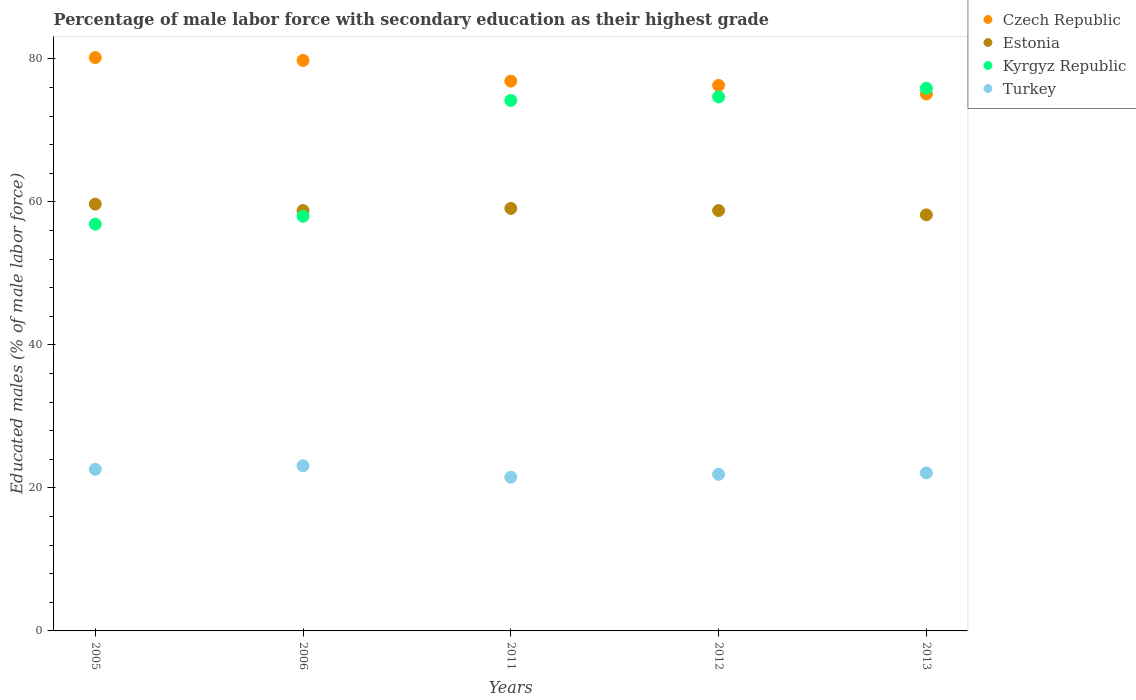Is the number of dotlines equal to the number of legend labels?
Your answer should be very brief. Yes. What is the percentage of male labor force with secondary education in Estonia in 2006?
Your response must be concise. 58.8. Across all years, what is the maximum percentage of male labor force with secondary education in Czech Republic?
Offer a terse response. 80.2. Across all years, what is the minimum percentage of male labor force with secondary education in Kyrgyz Republic?
Give a very brief answer. 56.9. What is the total percentage of male labor force with secondary education in Kyrgyz Republic in the graph?
Offer a terse response. 339.7. What is the difference between the percentage of male labor force with secondary education in Czech Republic in 2006 and that in 2013?
Provide a succinct answer. 4.7. What is the difference between the percentage of male labor force with secondary education in Turkey in 2006 and the percentage of male labor force with secondary education in Estonia in 2012?
Offer a terse response. -35.7. What is the average percentage of male labor force with secondary education in Kyrgyz Republic per year?
Provide a succinct answer. 67.94. In the year 2013, what is the difference between the percentage of male labor force with secondary education in Estonia and percentage of male labor force with secondary education in Turkey?
Offer a very short reply. 36.1. In how many years, is the percentage of male labor force with secondary education in Kyrgyz Republic greater than 44 %?
Make the answer very short. 5. What is the ratio of the percentage of male labor force with secondary education in Turkey in 2005 to that in 2012?
Give a very brief answer. 1.03. Is the difference between the percentage of male labor force with secondary education in Estonia in 2005 and 2012 greater than the difference between the percentage of male labor force with secondary education in Turkey in 2005 and 2012?
Offer a terse response. Yes. What is the difference between the highest and the second highest percentage of male labor force with secondary education in Kyrgyz Republic?
Give a very brief answer. 1.2. What is the difference between the highest and the lowest percentage of male labor force with secondary education in Czech Republic?
Make the answer very short. 5.1. In how many years, is the percentage of male labor force with secondary education in Turkey greater than the average percentage of male labor force with secondary education in Turkey taken over all years?
Ensure brevity in your answer.  2. Is the sum of the percentage of male labor force with secondary education in Turkey in 2011 and 2012 greater than the maximum percentage of male labor force with secondary education in Estonia across all years?
Give a very brief answer. No. Is it the case that in every year, the sum of the percentage of male labor force with secondary education in Estonia and percentage of male labor force with secondary education in Kyrgyz Republic  is greater than the sum of percentage of male labor force with secondary education in Czech Republic and percentage of male labor force with secondary education in Turkey?
Ensure brevity in your answer.  Yes. Does the percentage of male labor force with secondary education in Czech Republic monotonically increase over the years?
Ensure brevity in your answer.  No. Is the percentage of male labor force with secondary education in Kyrgyz Republic strictly greater than the percentage of male labor force with secondary education in Czech Republic over the years?
Ensure brevity in your answer.  No. Is the percentage of male labor force with secondary education in Czech Republic strictly less than the percentage of male labor force with secondary education in Turkey over the years?
Provide a short and direct response. No. How many years are there in the graph?
Your answer should be very brief. 5. Are the values on the major ticks of Y-axis written in scientific E-notation?
Your answer should be very brief. No. Does the graph contain any zero values?
Your answer should be compact. No. Does the graph contain grids?
Your response must be concise. No. How are the legend labels stacked?
Give a very brief answer. Vertical. What is the title of the graph?
Ensure brevity in your answer.  Percentage of male labor force with secondary education as their highest grade. Does "Uzbekistan" appear as one of the legend labels in the graph?
Your answer should be very brief. No. What is the label or title of the Y-axis?
Give a very brief answer. Educated males (% of male labor force). What is the Educated males (% of male labor force) of Czech Republic in 2005?
Keep it short and to the point. 80.2. What is the Educated males (% of male labor force) in Estonia in 2005?
Offer a terse response. 59.7. What is the Educated males (% of male labor force) in Kyrgyz Republic in 2005?
Make the answer very short. 56.9. What is the Educated males (% of male labor force) of Turkey in 2005?
Offer a very short reply. 22.6. What is the Educated males (% of male labor force) of Czech Republic in 2006?
Your answer should be very brief. 79.8. What is the Educated males (% of male labor force) of Estonia in 2006?
Your answer should be very brief. 58.8. What is the Educated males (% of male labor force) of Turkey in 2006?
Provide a succinct answer. 23.1. What is the Educated males (% of male labor force) of Czech Republic in 2011?
Offer a terse response. 76.9. What is the Educated males (% of male labor force) of Estonia in 2011?
Keep it short and to the point. 59.1. What is the Educated males (% of male labor force) in Kyrgyz Republic in 2011?
Ensure brevity in your answer.  74.2. What is the Educated males (% of male labor force) of Turkey in 2011?
Provide a short and direct response. 21.5. What is the Educated males (% of male labor force) of Czech Republic in 2012?
Keep it short and to the point. 76.3. What is the Educated males (% of male labor force) in Estonia in 2012?
Provide a short and direct response. 58.8. What is the Educated males (% of male labor force) in Kyrgyz Republic in 2012?
Keep it short and to the point. 74.7. What is the Educated males (% of male labor force) of Turkey in 2012?
Your response must be concise. 21.9. What is the Educated males (% of male labor force) in Czech Republic in 2013?
Give a very brief answer. 75.1. What is the Educated males (% of male labor force) of Estonia in 2013?
Offer a very short reply. 58.2. What is the Educated males (% of male labor force) of Kyrgyz Republic in 2013?
Provide a succinct answer. 75.9. What is the Educated males (% of male labor force) of Turkey in 2013?
Your answer should be compact. 22.1. Across all years, what is the maximum Educated males (% of male labor force) of Czech Republic?
Offer a very short reply. 80.2. Across all years, what is the maximum Educated males (% of male labor force) in Estonia?
Keep it short and to the point. 59.7. Across all years, what is the maximum Educated males (% of male labor force) in Kyrgyz Republic?
Ensure brevity in your answer.  75.9. Across all years, what is the maximum Educated males (% of male labor force) of Turkey?
Your answer should be compact. 23.1. Across all years, what is the minimum Educated males (% of male labor force) of Czech Republic?
Your answer should be compact. 75.1. Across all years, what is the minimum Educated males (% of male labor force) of Estonia?
Ensure brevity in your answer.  58.2. Across all years, what is the minimum Educated males (% of male labor force) of Kyrgyz Republic?
Give a very brief answer. 56.9. Across all years, what is the minimum Educated males (% of male labor force) of Turkey?
Give a very brief answer. 21.5. What is the total Educated males (% of male labor force) of Czech Republic in the graph?
Your answer should be compact. 388.3. What is the total Educated males (% of male labor force) in Estonia in the graph?
Provide a short and direct response. 294.6. What is the total Educated males (% of male labor force) in Kyrgyz Republic in the graph?
Your response must be concise. 339.7. What is the total Educated males (% of male labor force) of Turkey in the graph?
Provide a short and direct response. 111.2. What is the difference between the Educated males (% of male labor force) of Kyrgyz Republic in 2005 and that in 2006?
Your answer should be very brief. -1.1. What is the difference between the Educated males (% of male labor force) in Turkey in 2005 and that in 2006?
Keep it short and to the point. -0.5. What is the difference between the Educated males (% of male labor force) in Estonia in 2005 and that in 2011?
Provide a short and direct response. 0.6. What is the difference between the Educated males (% of male labor force) in Kyrgyz Republic in 2005 and that in 2011?
Provide a succinct answer. -17.3. What is the difference between the Educated males (% of male labor force) in Turkey in 2005 and that in 2011?
Give a very brief answer. 1.1. What is the difference between the Educated males (% of male labor force) of Czech Republic in 2005 and that in 2012?
Ensure brevity in your answer.  3.9. What is the difference between the Educated males (% of male labor force) of Kyrgyz Republic in 2005 and that in 2012?
Provide a succinct answer. -17.8. What is the difference between the Educated males (% of male labor force) of Turkey in 2005 and that in 2012?
Your answer should be compact. 0.7. What is the difference between the Educated males (% of male labor force) in Czech Republic in 2005 and that in 2013?
Ensure brevity in your answer.  5.1. What is the difference between the Educated males (% of male labor force) of Turkey in 2005 and that in 2013?
Your answer should be compact. 0.5. What is the difference between the Educated males (% of male labor force) of Estonia in 2006 and that in 2011?
Ensure brevity in your answer.  -0.3. What is the difference between the Educated males (% of male labor force) in Kyrgyz Republic in 2006 and that in 2011?
Your answer should be very brief. -16.2. What is the difference between the Educated males (% of male labor force) in Czech Republic in 2006 and that in 2012?
Ensure brevity in your answer.  3.5. What is the difference between the Educated males (% of male labor force) in Kyrgyz Republic in 2006 and that in 2012?
Give a very brief answer. -16.7. What is the difference between the Educated males (% of male labor force) in Turkey in 2006 and that in 2012?
Your answer should be compact. 1.2. What is the difference between the Educated males (% of male labor force) of Estonia in 2006 and that in 2013?
Keep it short and to the point. 0.6. What is the difference between the Educated males (% of male labor force) of Kyrgyz Republic in 2006 and that in 2013?
Offer a very short reply. -17.9. What is the difference between the Educated males (% of male labor force) of Turkey in 2006 and that in 2013?
Make the answer very short. 1. What is the difference between the Educated males (% of male labor force) in Czech Republic in 2011 and that in 2012?
Your answer should be compact. 0.6. What is the difference between the Educated males (% of male labor force) in Estonia in 2011 and that in 2013?
Give a very brief answer. 0.9. What is the difference between the Educated males (% of male labor force) of Estonia in 2012 and that in 2013?
Your response must be concise. 0.6. What is the difference between the Educated males (% of male labor force) in Kyrgyz Republic in 2012 and that in 2013?
Offer a very short reply. -1.2. What is the difference between the Educated males (% of male labor force) of Turkey in 2012 and that in 2013?
Offer a very short reply. -0.2. What is the difference between the Educated males (% of male labor force) in Czech Republic in 2005 and the Educated males (% of male labor force) in Estonia in 2006?
Keep it short and to the point. 21.4. What is the difference between the Educated males (% of male labor force) in Czech Republic in 2005 and the Educated males (% of male labor force) in Turkey in 2006?
Give a very brief answer. 57.1. What is the difference between the Educated males (% of male labor force) of Estonia in 2005 and the Educated males (% of male labor force) of Kyrgyz Republic in 2006?
Keep it short and to the point. 1.7. What is the difference between the Educated males (% of male labor force) in Estonia in 2005 and the Educated males (% of male labor force) in Turkey in 2006?
Your answer should be compact. 36.6. What is the difference between the Educated males (% of male labor force) in Kyrgyz Republic in 2005 and the Educated males (% of male labor force) in Turkey in 2006?
Offer a terse response. 33.8. What is the difference between the Educated males (% of male labor force) in Czech Republic in 2005 and the Educated males (% of male labor force) in Estonia in 2011?
Your response must be concise. 21.1. What is the difference between the Educated males (% of male labor force) in Czech Republic in 2005 and the Educated males (% of male labor force) in Turkey in 2011?
Keep it short and to the point. 58.7. What is the difference between the Educated males (% of male labor force) of Estonia in 2005 and the Educated males (% of male labor force) of Turkey in 2011?
Offer a very short reply. 38.2. What is the difference between the Educated males (% of male labor force) of Kyrgyz Republic in 2005 and the Educated males (% of male labor force) of Turkey in 2011?
Offer a very short reply. 35.4. What is the difference between the Educated males (% of male labor force) in Czech Republic in 2005 and the Educated males (% of male labor force) in Estonia in 2012?
Make the answer very short. 21.4. What is the difference between the Educated males (% of male labor force) of Czech Republic in 2005 and the Educated males (% of male labor force) of Turkey in 2012?
Ensure brevity in your answer.  58.3. What is the difference between the Educated males (% of male labor force) in Estonia in 2005 and the Educated males (% of male labor force) in Turkey in 2012?
Your answer should be very brief. 37.8. What is the difference between the Educated males (% of male labor force) in Czech Republic in 2005 and the Educated males (% of male labor force) in Kyrgyz Republic in 2013?
Offer a terse response. 4.3. What is the difference between the Educated males (% of male labor force) in Czech Republic in 2005 and the Educated males (% of male labor force) in Turkey in 2013?
Give a very brief answer. 58.1. What is the difference between the Educated males (% of male labor force) of Estonia in 2005 and the Educated males (% of male labor force) of Kyrgyz Republic in 2013?
Offer a very short reply. -16.2. What is the difference between the Educated males (% of male labor force) of Estonia in 2005 and the Educated males (% of male labor force) of Turkey in 2013?
Your answer should be very brief. 37.6. What is the difference between the Educated males (% of male labor force) of Kyrgyz Republic in 2005 and the Educated males (% of male labor force) of Turkey in 2013?
Offer a very short reply. 34.8. What is the difference between the Educated males (% of male labor force) of Czech Republic in 2006 and the Educated males (% of male labor force) of Estonia in 2011?
Make the answer very short. 20.7. What is the difference between the Educated males (% of male labor force) of Czech Republic in 2006 and the Educated males (% of male labor force) of Turkey in 2011?
Your answer should be compact. 58.3. What is the difference between the Educated males (% of male labor force) in Estonia in 2006 and the Educated males (% of male labor force) in Kyrgyz Republic in 2011?
Make the answer very short. -15.4. What is the difference between the Educated males (% of male labor force) of Estonia in 2006 and the Educated males (% of male labor force) of Turkey in 2011?
Keep it short and to the point. 37.3. What is the difference between the Educated males (% of male labor force) of Kyrgyz Republic in 2006 and the Educated males (% of male labor force) of Turkey in 2011?
Provide a short and direct response. 36.5. What is the difference between the Educated males (% of male labor force) in Czech Republic in 2006 and the Educated males (% of male labor force) in Estonia in 2012?
Offer a very short reply. 21. What is the difference between the Educated males (% of male labor force) in Czech Republic in 2006 and the Educated males (% of male labor force) in Turkey in 2012?
Your answer should be compact. 57.9. What is the difference between the Educated males (% of male labor force) of Estonia in 2006 and the Educated males (% of male labor force) of Kyrgyz Republic in 2012?
Your answer should be very brief. -15.9. What is the difference between the Educated males (% of male labor force) of Estonia in 2006 and the Educated males (% of male labor force) of Turkey in 2012?
Ensure brevity in your answer.  36.9. What is the difference between the Educated males (% of male labor force) in Kyrgyz Republic in 2006 and the Educated males (% of male labor force) in Turkey in 2012?
Offer a terse response. 36.1. What is the difference between the Educated males (% of male labor force) of Czech Republic in 2006 and the Educated males (% of male labor force) of Estonia in 2013?
Provide a succinct answer. 21.6. What is the difference between the Educated males (% of male labor force) of Czech Republic in 2006 and the Educated males (% of male labor force) of Turkey in 2013?
Offer a terse response. 57.7. What is the difference between the Educated males (% of male labor force) of Estonia in 2006 and the Educated males (% of male labor force) of Kyrgyz Republic in 2013?
Keep it short and to the point. -17.1. What is the difference between the Educated males (% of male labor force) of Estonia in 2006 and the Educated males (% of male labor force) of Turkey in 2013?
Ensure brevity in your answer.  36.7. What is the difference between the Educated males (% of male labor force) in Kyrgyz Republic in 2006 and the Educated males (% of male labor force) in Turkey in 2013?
Give a very brief answer. 35.9. What is the difference between the Educated males (% of male labor force) of Czech Republic in 2011 and the Educated males (% of male labor force) of Estonia in 2012?
Give a very brief answer. 18.1. What is the difference between the Educated males (% of male labor force) of Czech Republic in 2011 and the Educated males (% of male labor force) of Turkey in 2012?
Provide a succinct answer. 55. What is the difference between the Educated males (% of male labor force) of Estonia in 2011 and the Educated males (% of male labor force) of Kyrgyz Republic in 2012?
Your answer should be very brief. -15.6. What is the difference between the Educated males (% of male labor force) of Estonia in 2011 and the Educated males (% of male labor force) of Turkey in 2012?
Your response must be concise. 37.2. What is the difference between the Educated males (% of male labor force) in Kyrgyz Republic in 2011 and the Educated males (% of male labor force) in Turkey in 2012?
Offer a very short reply. 52.3. What is the difference between the Educated males (% of male labor force) of Czech Republic in 2011 and the Educated males (% of male labor force) of Estonia in 2013?
Provide a short and direct response. 18.7. What is the difference between the Educated males (% of male labor force) in Czech Republic in 2011 and the Educated males (% of male labor force) in Turkey in 2013?
Make the answer very short. 54.8. What is the difference between the Educated males (% of male labor force) of Estonia in 2011 and the Educated males (% of male labor force) of Kyrgyz Republic in 2013?
Make the answer very short. -16.8. What is the difference between the Educated males (% of male labor force) in Estonia in 2011 and the Educated males (% of male labor force) in Turkey in 2013?
Offer a very short reply. 37. What is the difference between the Educated males (% of male labor force) of Kyrgyz Republic in 2011 and the Educated males (% of male labor force) of Turkey in 2013?
Keep it short and to the point. 52.1. What is the difference between the Educated males (% of male labor force) in Czech Republic in 2012 and the Educated males (% of male labor force) in Turkey in 2013?
Provide a short and direct response. 54.2. What is the difference between the Educated males (% of male labor force) of Estonia in 2012 and the Educated males (% of male labor force) of Kyrgyz Republic in 2013?
Ensure brevity in your answer.  -17.1. What is the difference between the Educated males (% of male labor force) of Estonia in 2012 and the Educated males (% of male labor force) of Turkey in 2013?
Give a very brief answer. 36.7. What is the difference between the Educated males (% of male labor force) in Kyrgyz Republic in 2012 and the Educated males (% of male labor force) in Turkey in 2013?
Offer a very short reply. 52.6. What is the average Educated males (% of male labor force) of Czech Republic per year?
Ensure brevity in your answer.  77.66. What is the average Educated males (% of male labor force) of Estonia per year?
Offer a terse response. 58.92. What is the average Educated males (% of male labor force) in Kyrgyz Republic per year?
Your answer should be very brief. 67.94. What is the average Educated males (% of male labor force) in Turkey per year?
Your response must be concise. 22.24. In the year 2005, what is the difference between the Educated males (% of male labor force) in Czech Republic and Educated males (% of male labor force) in Kyrgyz Republic?
Keep it short and to the point. 23.3. In the year 2005, what is the difference between the Educated males (% of male labor force) in Czech Republic and Educated males (% of male labor force) in Turkey?
Offer a terse response. 57.6. In the year 2005, what is the difference between the Educated males (% of male labor force) in Estonia and Educated males (% of male labor force) in Kyrgyz Republic?
Your response must be concise. 2.8. In the year 2005, what is the difference between the Educated males (% of male labor force) of Estonia and Educated males (% of male labor force) of Turkey?
Provide a short and direct response. 37.1. In the year 2005, what is the difference between the Educated males (% of male labor force) of Kyrgyz Republic and Educated males (% of male labor force) of Turkey?
Make the answer very short. 34.3. In the year 2006, what is the difference between the Educated males (% of male labor force) of Czech Republic and Educated males (% of male labor force) of Estonia?
Make the answer very short. 21. In the year 2006, what is the difference between the Educated males (% of male labor force) in Czech Republic and Educated males (% of male labor force) in Kyrgyz Republic?
Your response must be concise. 21.8. In the year 2006, what is the difference between the Educated males (% of male labor force) in Czech Republic and Educated males (% of male labor force) in Turkey?
Make the answer very short. 56.7. In the year 2006, what is the difference between the Educated males (% of male labor force) of Estonia and Educated males (% of male labor force) of Turkey?
Give a very brief answer. 35.7. In the year 2006, what is the difference between the Educated males (% of male labor force) in Kyrgyz Republic and Educated males (% of male labor force) in Turkey?
Provide a short and direct response. 34.9. In the year 2011, what is the difference between the Educated males (% of male labor force) in Czech Republic and Educated males (% of male labor force) in Turkey?
Make the answer very short. 55.4. In the year 2011, what is the difference between the Educated males (% of male labor force) of Estonia and Educated males (% of male labor force) of Kyrgyz Republic?
Your answer should be compact. -15.1. In the year 2011, what is the difference between the Educated males (% of male labor force) of Estonia and Educated males (% of male labor force) of Turkey?
Offer a very short reply. 37.6. In the year 2011, what is the difference between the Educated males (% of male labor force) in Kyrgyz Republic and Educated males (% of male labor force) in Turkey?
Offer a terse response. 52.7. In the year 2012, what is the difference between the Educated males (% of male labor force) of Czech Republic and Educated males (% of male labor force) of Turkey?
Give a very brief answer. 54.4. In the year 2012, what is the difference between the Educated males (% of male labor force) in Estonia and Educated males (% of male labor force) in Kyrgyz Republic?
Keep it short and to the point. -15.9. In the year 2012, what is the difference between the Educated males (% of male labor force) of Estonia and Educated males (% of male labor force) of Turkey?
Make the answer very short. 36.9. In the year 2012, what is the difference between the Educated males (% of male labor force) in Kyrgyz Republic and Educated males (% of male labor force) in Turkey?
Make the answer very short. 52.8. In the year 2013, what is the difference between the Educated males (% of male labor force) in Czech Republic and Educated males (% of male labor force) in Estonia?
Your answer should be very brief. 16.9. In the year 2013, what is the difference between the Educated males (% of male labor force) of Czech Republic and Educated males (% of male labor force) of Kyrgyz Republic?
Provide a succinct answer. -0.8. In the year 2013, what is the difference between the Educated males (% of male labor force) in Czech Republic and Educated males (% of male labor force) in Turkey?
Your answer should be very brief. 53. In the year 2013, what is the difference between the Educated males (% of male labor force) of Estonia and Educated males (% of male labor force) of Kyrgyz Republic?
Your response must be concise. -17.7. In the year 2013, what is the difference between the Educated males (% of male labor force) of Estonia and Educated males (% of male labor force) of Turkey?
Provide a succinct answer. 36.1. In the year 2013, what is the difference between the Educated males (% of male labor force) of Kyrgyz Republic and Educated males (% of male labor force) of Turkey?
Provide a short and direct response. 53.8. What is the ratio of the Educated males (% of male labor force) in Estonia in 2005 to that in 2006?
Provide a succinct answer. 1.02. What is the ratio of the Educated males (% of male labor force) of Turkey in 2005 to that in 2006?
Your answer should be very brief. 0.98. What is the ratio of the Educated males (% of male labor force) in Czech Republic in 2005 to that in 2011?
Your answer should be compact. 1.04. What is the ratio of the Educated males (% of male labor force) of Estonia in 2005 to that in 2011?
Your answer should be very brief. 1.01. What is the ratio of the Educated males (% of male labor force) in Kyrgyz Republic in 2005 to that in 2011?
Make the answer very short. 0.77. What is the ratio of the Educated males (% of male labor force) of Turkey in 2005 to that in 2011?
Provide a succinct answer. 1.05. What is the ratio of the Educated males (% of male labor force) of Czech Republic in 2005 to that in 2012?
Provide a short and direct response. 1.05. What is the ratio of the Educated males (% of male labor force) of Estonia in 2005 to that in 2012?
Your response must be concise. 1.02. What is the ratio of the Educated males (% of male labor force) in Kyrgyz Republic in 2005 to that in 2012?
Provide a short and direct response. 0.76. What is the ratio of the Educated males (% of male labor force) in Turkey in 2005 to that in 2012?
Your answer should be compact. 1.03. What is the ratio of the Educated males (% of male labor force) in Czech Republic in 2005 to that in 2013?
Make the answer very short. 1.07. What is the ratio of the Educated males (% of male labor force) of Estonia in 2005 to that in 2013?
Your response must be concise. 1.03. What is the ratio of the Educated males (% of male labor force) of Kyrgyz Republic in 2005 to that in 2013?
Make the answer very short. 0.75. What is the ratio of the Educated males (% of male labor force) in Turkey in 2005 to that in 2013?
Make the answer very short. 1.02. What is the ratio of the Educated males (% of male labor force) of Czech Republic in 2006 to that in 2011?
Offer a very short reply. 1.04. What is the ratio of the Educated males (% of male labor force) of Estonia in 2006 to that in 2011?
Your answer should be very brief. 0.99. What is the ratio of the Educated males (% of male labor force) in Kyrgyz Republic in 2006 to that in 2011?
Your answer should be very brief. 0.78. What is the ratio of the Educated males (% of male labor force) in Turkey in 2006 to that in 2011?
Your answer should be very brief. 1.07. What is the ratio of the Educated males (% of male labor force) in Czech Republic in 2006 to that in 2012?
Make the answer very short. 1.05. What is the ratio of the Educated males (% of male labor force) of Estonia in 2006 to that in 2012?
Offer a very short reply. 1. What is the ratio of the Educated males (% of male labor force) in Kyrgyz Republic in 2006 to that in 2012?
Give a very brief answer. 0.78. What is the ratio of the Educated males (% of male labor force) of Turkey in 2006 to that in 2012?
Your answer should be very brief. 1.05. What is the ratio of the Educated males (% of male labor force) of Czech Republic in 2006 to that in 2013?
Your answer should be compact. 1.06. What is the ratio of the Educated males (% of male labor force) of Estonia in 2006 to that in 2013?
Offer a terse response. 1.01. What is the ratio of the Educated males (% of male labor force) in Kyrgyz Republic in 2006 to that in 2013?
Ensure brevity in your answer.  0.76. What is the ratio of the Educated males (% of male labor force) in Turkey in 2006 to that in 2013?
Offer a terse response. 1.05. What is the ratio of the Educated males (% of male labor force) in Czech Republic in 2011 to that in 2012?
Ensure brevity in your answer.  1.01. What is the ratio of the Educated males (% of male labor force) in Estonia in 2011 to that in 2012?
Ensure brevity in your answer.  1.01. What is the ratio of the Educated males (% of male labor force) of Turkey in 2011 to that in 2012?
Give a very brief answer. 0.98. What is the ratio of the Educated males (% of male labor force) in Estonia in 2011 to that in 2013?
Ensure brevity in your answer.  1.02. What is the ratio of the Educated males (% of male labor force) of Kyrgyz Republic in 2011 to that in 2013?
Offer a very short reply. 0.98. What is the ratio of the Educated males (% of male labor force) of Turkey in 2011 to that in 2013?
Provide a short and direct response. 0.97. What is the ratio of the Educated males (% of male labor force) of Czech Republic in 2012 to that in 2013?
Your answer should be very brief. 1.02. What is the ratio of the Educated males (% of male labor force) of Estonia in 2012 to that in 2013?
Give a very brief answer. 1.01. What is the ratio of the Educated males (% of male labor force) of Kyrgyz Republic in 2012 to that in 2013?
Offer a very short reply. 0.98. What is the ratio of the Educated males (% of male labor force) in Turkey in 2012 to that in 2013?
Make the answer very short. 0.99. What is the difference between the highest and the second highest Educated males (% of male labor force) in Kyrgyz Republic?
Make the answer very short. 1.2. What is the difference between the highest and the second highest Educated males (% of male labor force) in Turkey?
Offer a very short reply. 0.5. What is the difference between the highest and the lowest Educated males (% of male labor force) in Czech Republic?
Provide a short and direct response. 5.1. What is the difference between the highest and the lowest Educated males (% of male labor force) of Estonia?
Provide a short and direct response. 1.5. What is the difference between the highest and the lowest Educated males (% of male labor force) of Kyrgyz Republic?
Provide a short and direct response. 19. 